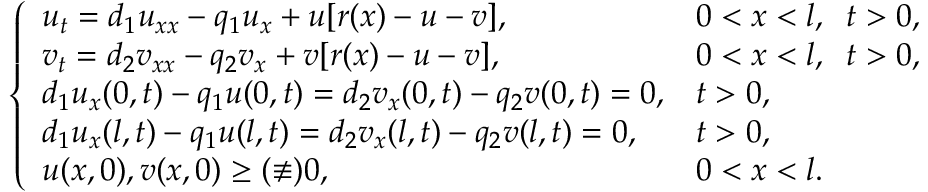<formula> <loc_0><loc_0><loc_500><loc_500>\left \{ \begin{array} { l l } { u _ { t } = d _ { 1 } u _ { x x } - q _ { 1 } u _ { x } + u [ r ( x ) - u - v ] , } & { 0 < x < l , \, t > 0 , } \\ { v _ { t } = d _ { 2 } v _ { x x } - q _ { 2 } v _ { x } + v [ r ( x ) - u - v ] , } & { 0 < x < l , \, t > 0 , } \\ { d _ { 1 } u _ { x } ( 0 , t ) - q _ { 1 } u ( 0 , t ) = d _ { 2 } v _ { x } ( 0 , t ) - q _ { 2 } v ( 0 , t ) = 0 , } & { t > 0 , } \\ { d _ { 1 } u _ { x } ( l , t ) - q _ { 1 } u ( l , t ) = d _ { 2 } v _ { x } ( l , t ) - q _ { 2 } v ( l , t ) = 0 , } & { t > 0 , } \\ { u ( x , 0 ) , v ( x , 0 ) \geq ( \not \equiv ) 0 , } & { 0 < x < l . } \end{array}</formula> 